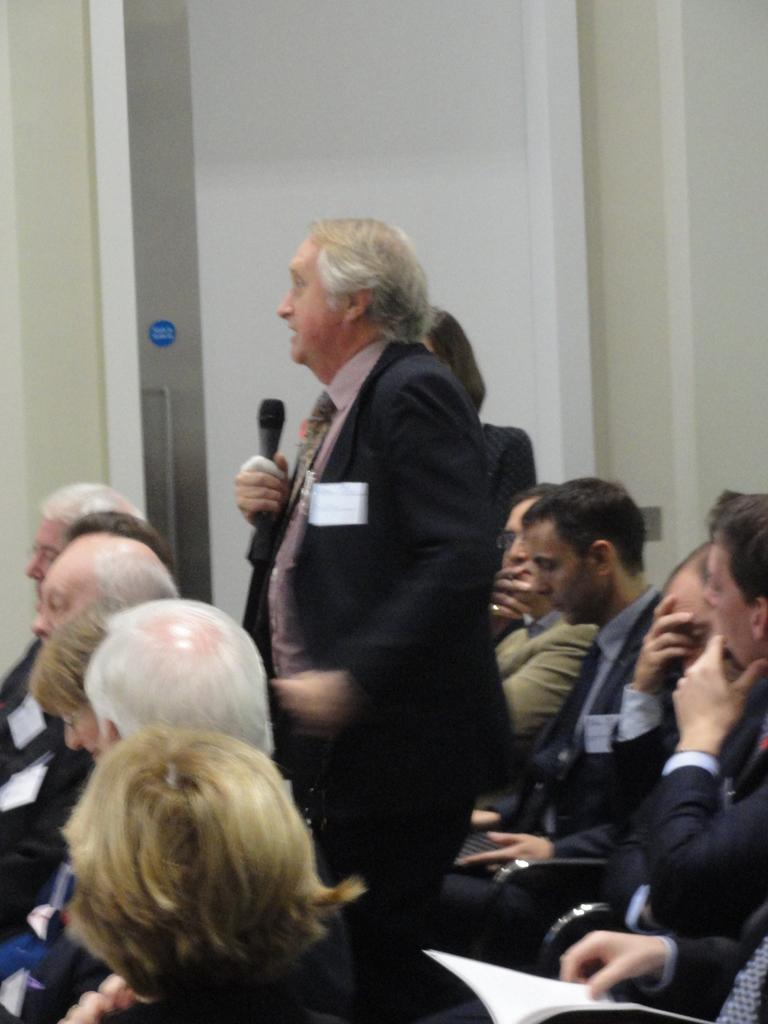How many people are standing in the image? There are two persons standing in the image. What is one of the persons holding? One person is holding a microphone in the image. What are the other people in the image doing? There is a group of people sitting on chairs in the image. What can be seen in the background of the image? There is a wall and a door in the background of the image. What type of wish can be granted by the person holding the microphone in the image? There is no indication in the image that the person holding the microphone can grant wishes. 